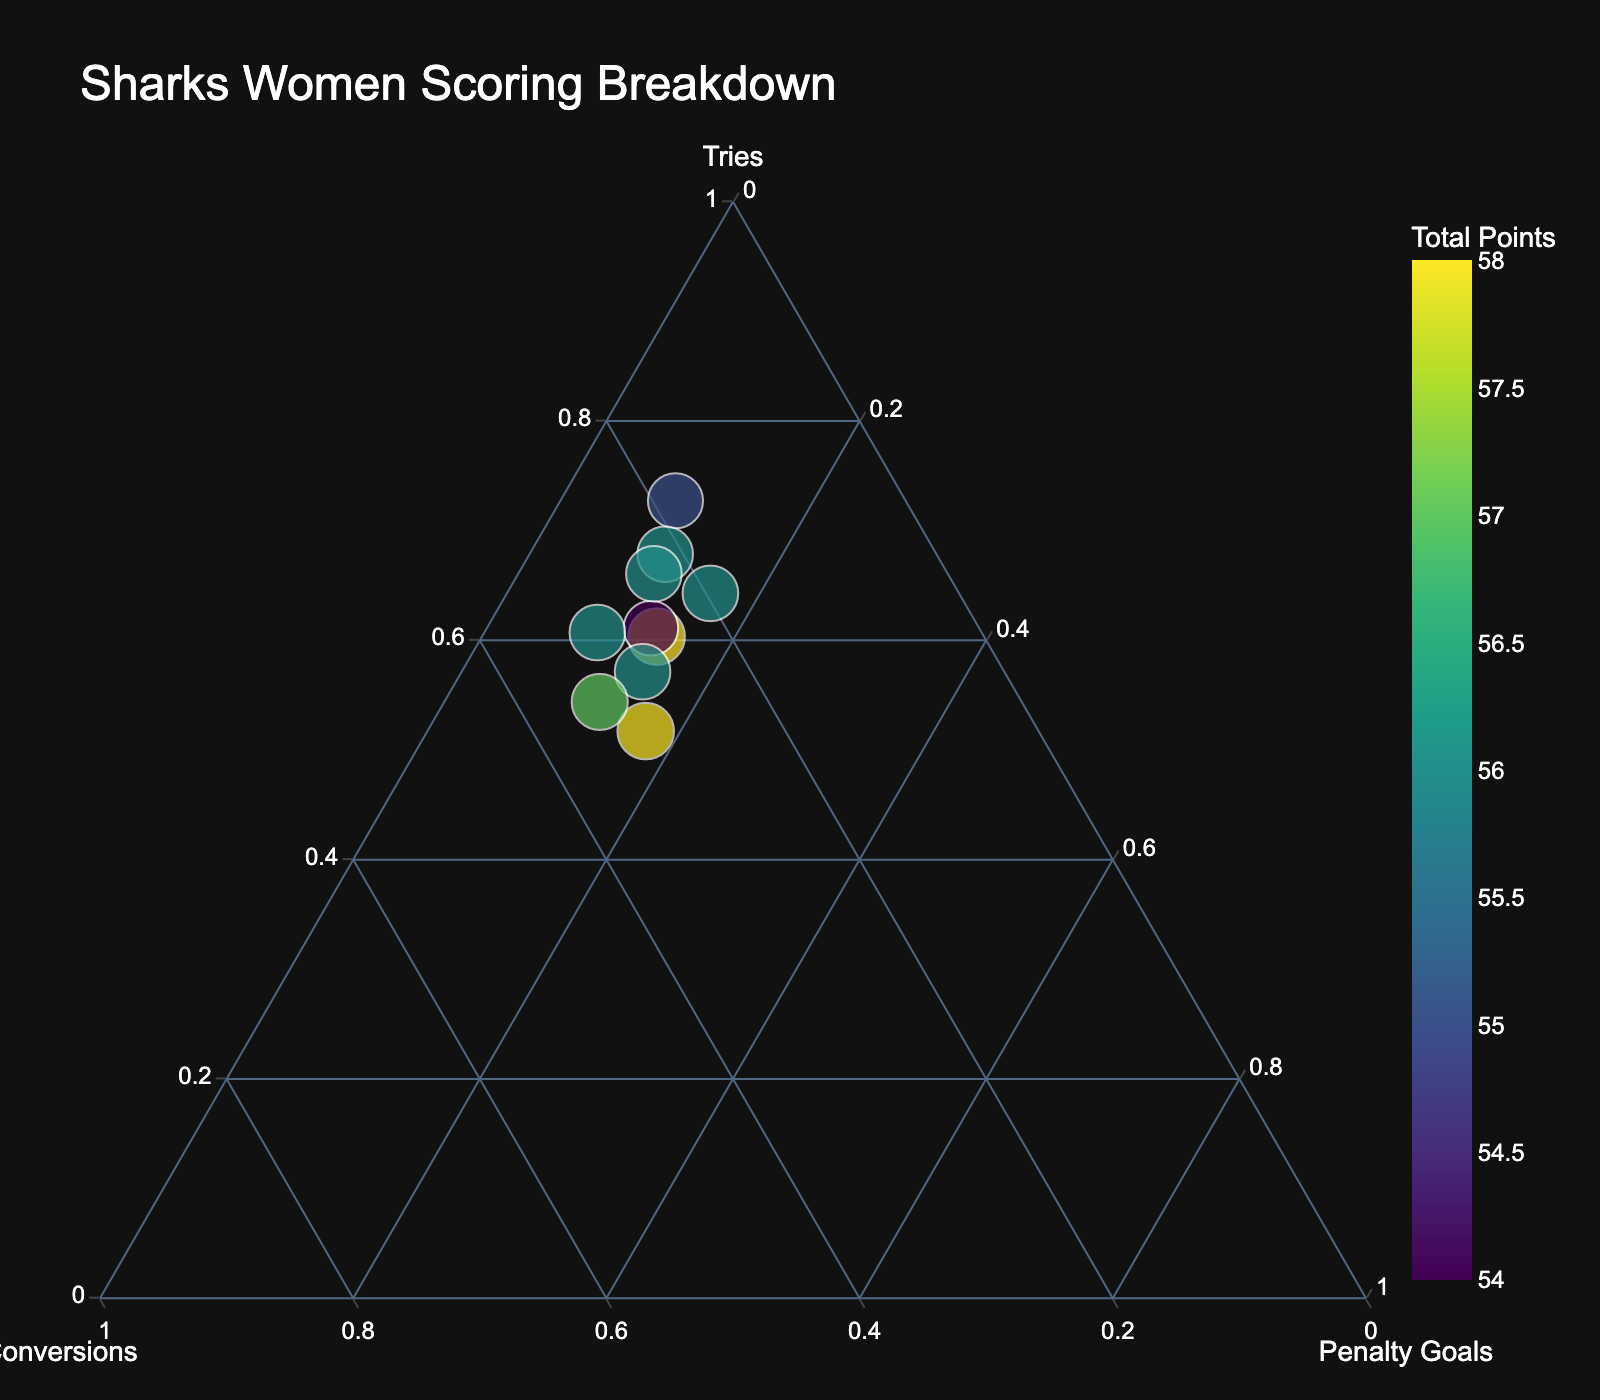Which player scored the most tries? By looking at the point represented primarily by the 'Tries' axis, we see that Tiana Penitani's position is closest to the 'Tries' axis.
Answer: Tiana Penitani How many players have more than 15 conversions? by counting the players whose points are closer to the 'Conversions' axis while being farther from the center. The players are Quincy Dodd, Teagan Berry, and Andie Robinson.
Answer: 3 Which player has the smallest total score? The size of the points represents the total score. By looking at the smallest dot in the figure, it is Ellie Johnston.
Answer: Ellie Johnston What is the highest combined score of penalty goals and conversions by a player? To find this, look for the player whose combined fraction for penalties and conversions is the highest. Quincy Dodd has 28 combined points, which is more than any other player.
Answer: 28 Is any player's scoring heavily dominated by penalty goals? The player closest to the 'Penalty Goals' axis is Quincy Dodd, indicating a higher proportion of penalty goals. However, no player is dominated by penalty goals.
Answer: No Which player has the most balanced scoring across all three methods? A balanced scoring will appear more towards the center of the ternary plot. Andie Robinson's point is closest to the center.
Answer: Andie Robinson Who scored more total: Jada Taylor or Taliah Fuimaono? By comparing the size of the points color-coded by total scores, Jada Taylor has a slightly larger dot than Taliah Fuimaono.
Answer: Jada Taylor What is the total number of tries scored by Emma Tonegato? Spot Emma Tonegato's point and note her size. Since the data table provides the exact numbers, Emma Tonegato scored 38 tries.
Answer: 38 